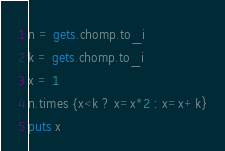Convert code to text. <code><loc_0><loc_0><loc_500><loc_500><_Ruby_>n = gets.chomp.to_i
k = gets.chomp.to_i
x = 1
n.times {x<k ? x=x*2 : x=x+k}
puts x</code> 